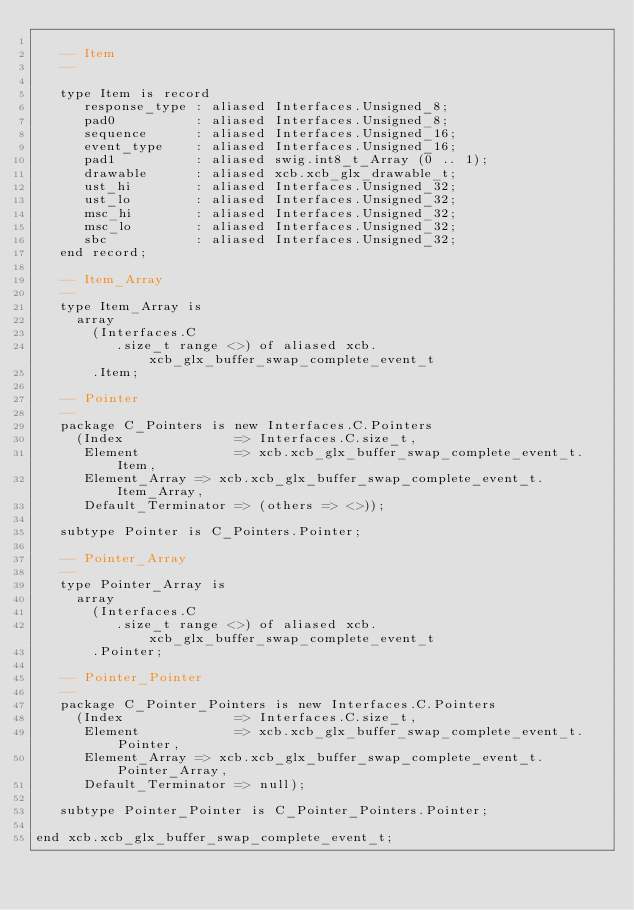<code> <loc_0><loc_0><loc_500><loc_500><_Ada_>
   -- Item
   --

   type Item is record
      response_type : aliased Interfaces.Unsigned_8;
      pad0          : aliased Interfaces.Unsigned_8;
      sequence      : aliased Interfaces.Unsigned_16;
      event_type    : aliased Interfaces.Unsigned_16;
      pad1          : aliased swig.int8_t_Array (0 .. 1);
      drawable      : aliased xcb.xcb_glx_drawable_t;
      ust_hi        : aliased Interfaces.Unsigned_32;
      ust_lo        : aliased Interfaces.Unsigned_32;
      msc_hi        : aliased Interfaces.Unsigned_32;
      msc_lo        : aliased Interfaces.Unsigned_32;
      sbc           : aliased Interfaces.Unsigned_32;
   end record;

   -- Item_Array
   --
   type Item_Array is
     array
       (Interfaces.C
          .size_t range <>) of aliased xcb.xcb_glx_buffer_swap_complete_event_t
       .Item;

   -- Pointer
   --
   package C_Pointers is new Interfaces.C.Pointers
     (Index              => Interfaces.C.size_t,
      Element            => xcb.xcb_glx_buffer_swap_complete_event_t.Item,
      Element_Array => xcb.xcb_glx_buffer_swap_complete_event_t.Item_Array,
      Default_Terminator => (others => <>));

   subtype Pointer is C_Pointers.Pointer;

   -- Pointer_Array
   --
   type Pointer_Array is
     array
       (Interfaces.C
          .size_t range <>) of aliased xcb.xcb_glx_buffer_swap_complete_event_t
       .Pointer;

   -- Pointer_Pointer
   --
   package C_Pointer_Pointers is new Interfaces.C.Pointers
     (Index              => Interfaces.C.size_t,
      Element            => xcb.xcb_glx_buffer_swap_complete_event_t.Pointer,
      Element_Array => xcb.xcb_glx_buffer_swap_complete_event_t.Pointer_Array,
      Default_Terminator => null);

   subtype Pointer_Pointer is C_Pointer_Pointers.Pointer;

end xcb.xcb_glx_buffer_swap_complete_event_t;
</code> 